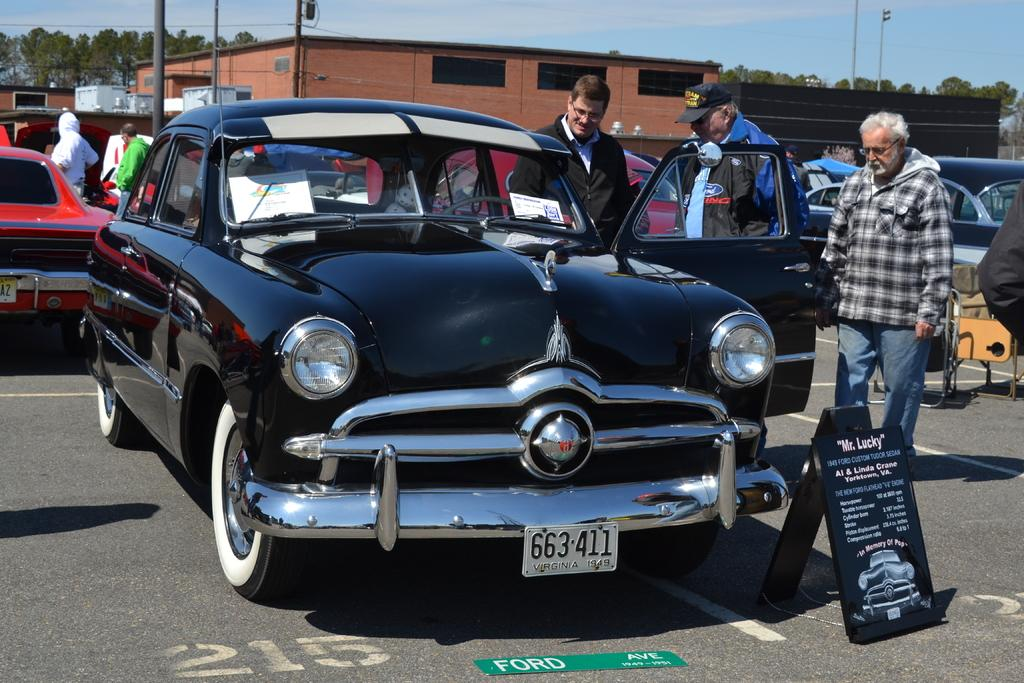What types of motor vehicles can be seen in the image? There are motor vehicles in the image, but the specific types cannot be determined from the provided facts. What is the person standing on the road doing? The person's actions cannot be determined from the provided facts. What are the name boards used for in the image? Name boards are present in the image, but their purpose cannot be determined from the provided facts. Can you describe the buildings in the image? There are buildings in the image, but their specific characteristics cannot be determined from the provided facts. What are the poles used for in the image? Poles are visible in the image, but their purpose cannot be determined from the provided facts. What are the cables used for in the image? Cables are present in the image, but their purpose cannot be determined from the provided facts. What type of vegetation is visible in the image? Trees are visible in the image. What is visible in the sky in the image? The sky is visible in the image, and clouds are present. Where is the kettle located in the image? There is no kettle present in the image. What type of sand can be seen on the road in the image? There is no sand visible on the road in the image. 